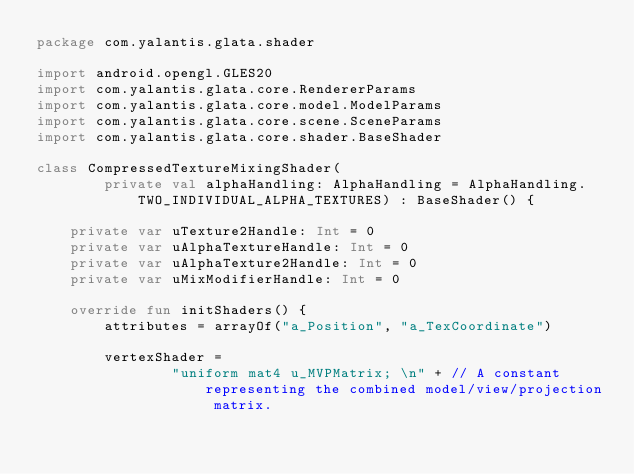<code> <loc_0><loc_0><loc_500><loc_500><_Kotlin_>package com.yalantis.glata.shader

import android.opengl.GLES20
import com.yalantis.glata.core.RendererParams
import com.yalantis.glata.core.model.ModelParams
import com.yalantis.glata.core.scene.SceneParams
import com.yalantis.glata.core.shader.BaseShader

class CompressedTextureMixingShader(
        private val alphaHandling: AlphaHandling = AlphaHandling.TWO_INDIVIDUAL_ALPHA_TEXTURES) : BaseShader() {

    private var uTexture2Handle: Int = 0
    private var uAlphaTextureHandle: Int = 0
    private var uAlphaTexture2Handle: Int = 0
    private var uMixModifierHandle: Int = 0

    override fun initShaders() {
        attributes = arrayOf("a_Position", "a_TexCoordinate")

        vertexShader =
                "uniform mat4 u_MVPMatrix; \n" + // A constant representing the combined model/view/projection matrix.</code> 